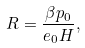<formula> <loc_0><loc_0><loc_500><loc_500>R = \frac { \beta p _ { 0 } } { e _ { 0 } H } ,</formula> 